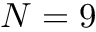Convert formula to latex. <formula><loc_0><loc_0><loc_500><loc_500>N = 9</formula> 